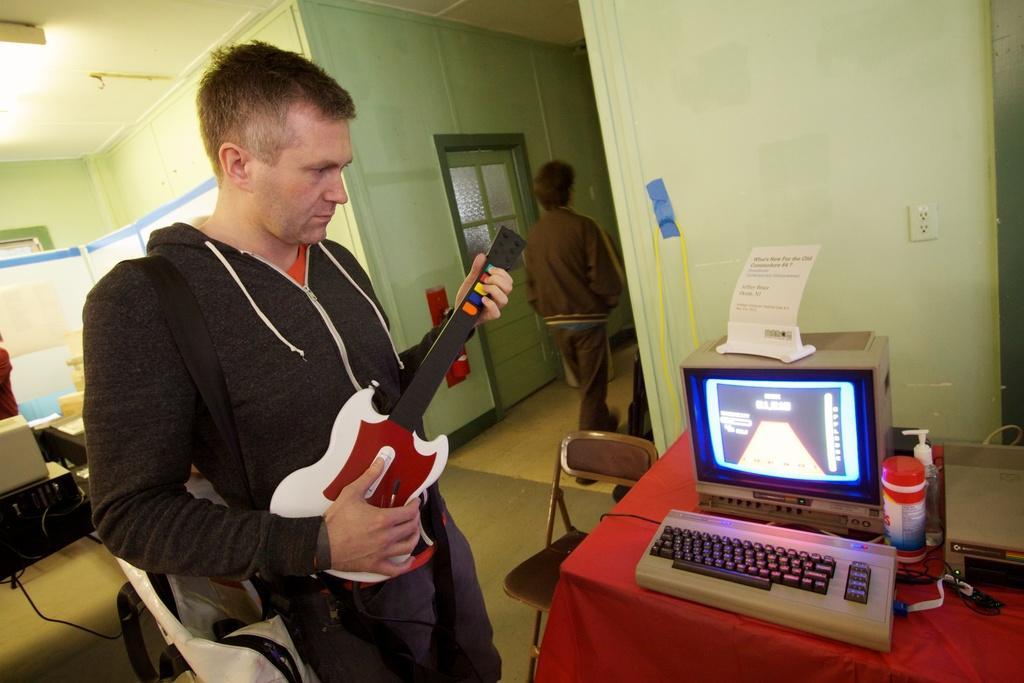Could you give a brief overview of what you see in this image? In this image I can see a person holding the toy guitar. In front of him there is a system on the table. In the background there is a person walking. 